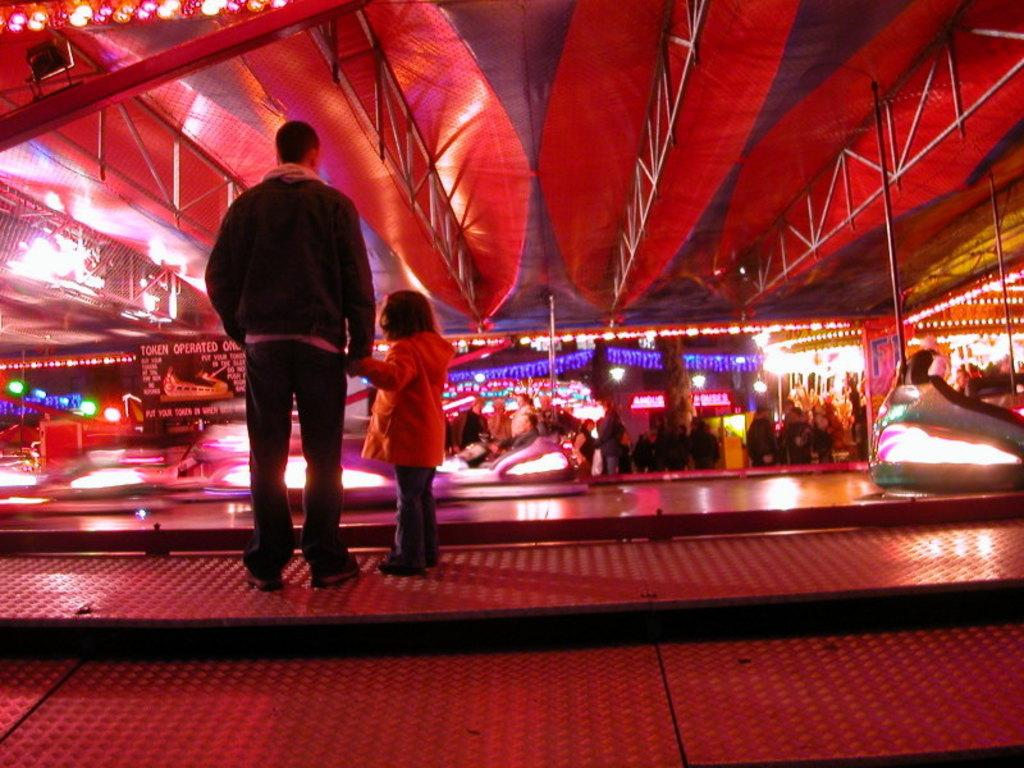What is the main subject in the center of the image? There is a person standing in the center of the image. Can you describe the relationship between the person and the child in the image? The presence of a child in the image suggests that the person might be a parent, guardian, or caregiver. What can be observed about the surrounding environment in the image? There are many people in the background of the image. What type of sock is the person wearing in the image? There is no information about the person's socks in the image, so it cannot be determined. 